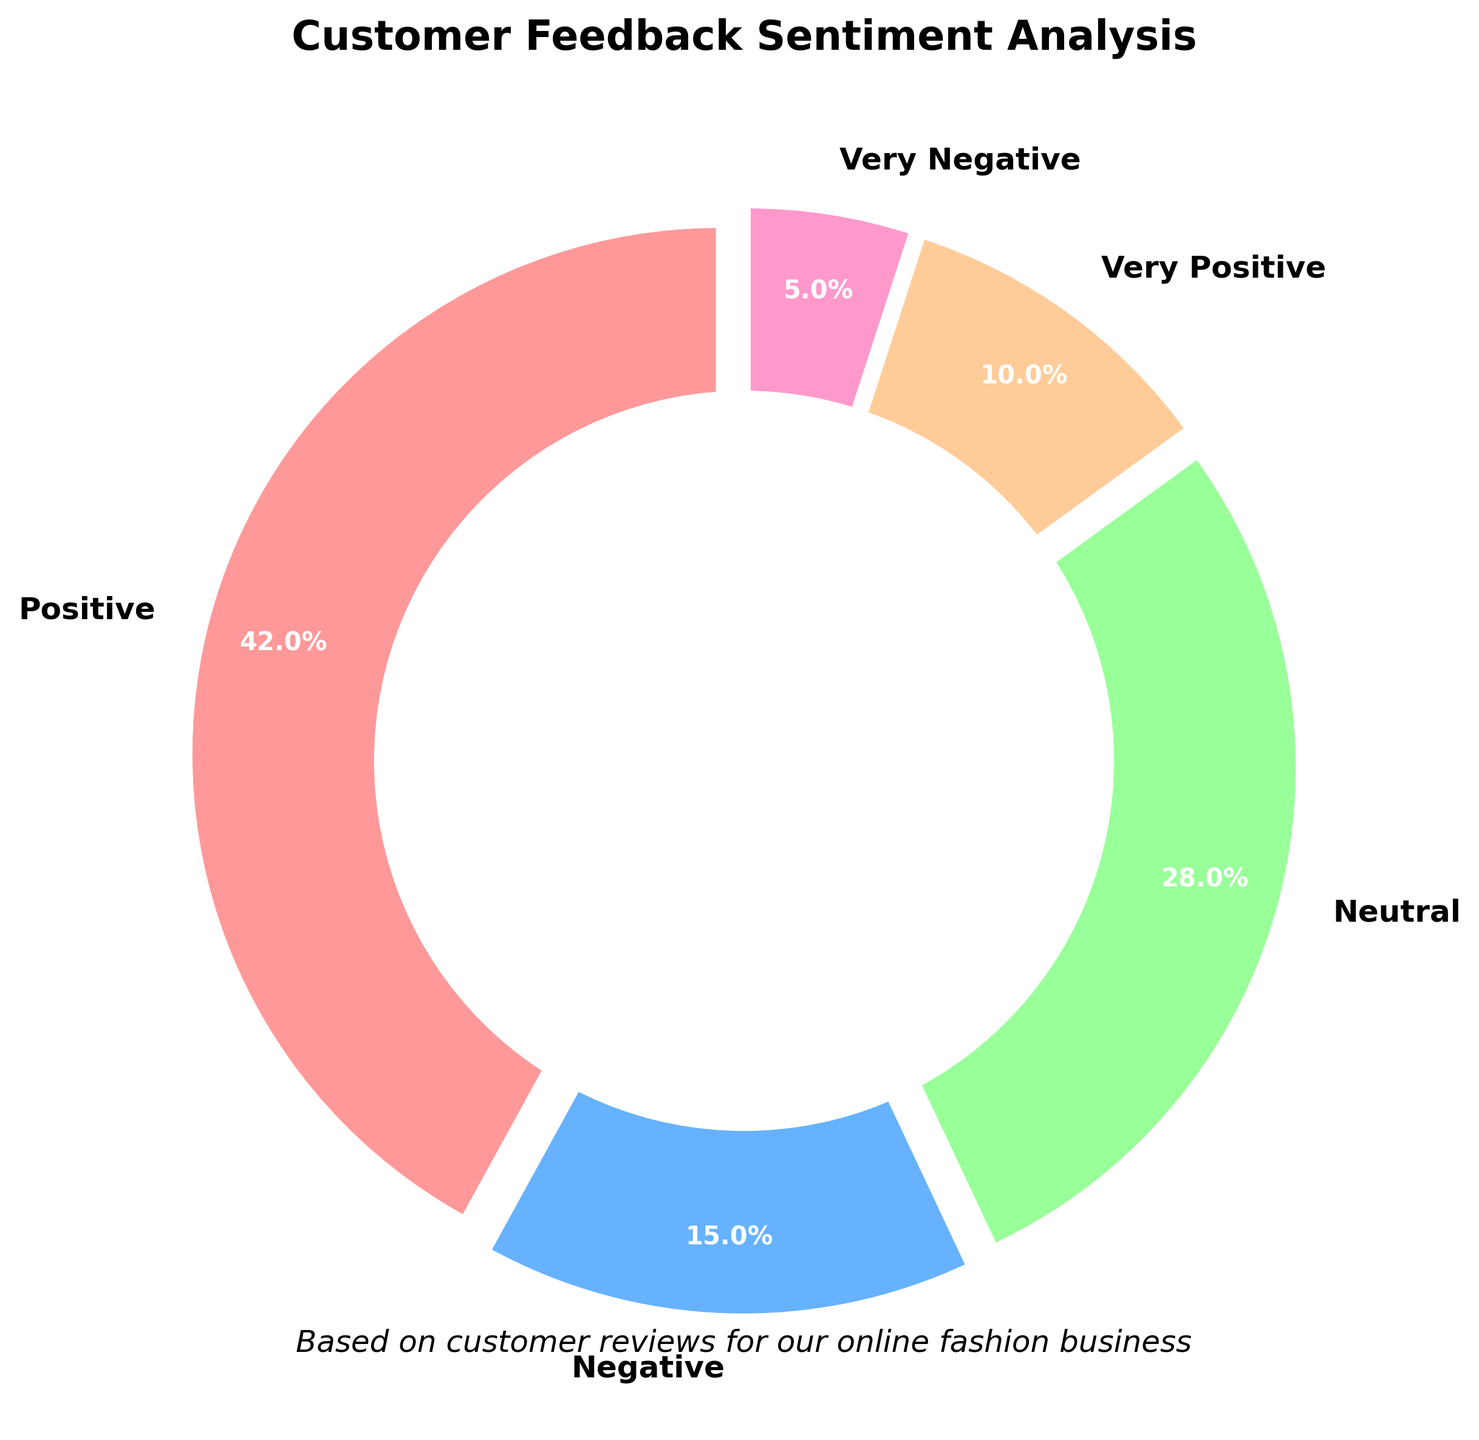What percentage of customer feedback is either very positive or very negative? To find the combined percentage of "Very Positive" and "Very Negative" feedbacks, add their individual percentages: 10% + 5%.
Answer: 15% Which sentiment category has the highest percentage? From the pie chart, identify the segment with the largest proportion. The "Positive" category has the highest percentage at 42%.
Answer: Positive How much more positive feedback is there compared to negative feedback? The positive feedback is 42%, and the negative feedback is 15%. Subtract the percentage of negative feedback from positive feedback: 42% - 15%.
Answer: 27% What proportion of the feedback falls under a neutral sentiment? The segment labeled "Neutral" represents feedback with a neutral sentiment. According to the chart, it accounts for 28% of the feedback.
Answer: 28% Which sentiment category is least represented? Look for the segment with the smallest proportion. The "Very Negative" category represents 5%, which is the smallest.
Answer: Very Negative How much feedback is categorized as very positive relative to all positive feedback (positive + very positive)? First, add the percentages of "Positive" and "Very Positive" sentiments: 42% + 10% = 52%. Then, calculate the proportion of "Very Positive" feedback out of the total positive feedback: (10% / 52%) * 100%. This yields approximately 19.2%.
Answer: 19.2% Is there more neutral feedback than negative feedback? Compare the sizes of the "Neutral" and "Negative" segments. The "Neutral" segment is 28%, while the "Negative" segment is 15%.
Answer: Yes What is the combined percentage of neutral and negative feedback? Add the percentages of "Neutral" and "Negative" sentiments: 28% + 15%.
Answer: 43% If you combine positive and very positive feedback, what percentage of the total feedback do they represent? Add the percentages of "Positive" and "Very Positive" sentiments: 42% + 10%.
Answer: 52% How does the percentage of very negative feedback compare to neutral feedback? Compare the sizes of the "Very Negative" (5%) and "Neutral" (28%) segments by calculating the difference: 28% - 5%.
Answer: 23% 